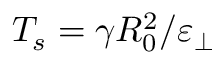Convert formula to latex. <formula><loc_0><loc_0><loc_500><loc_500>T _ { s } = \gamma R _ { 0 } ^ { 2 } / \varepsilon _ { \perp }</formula> 